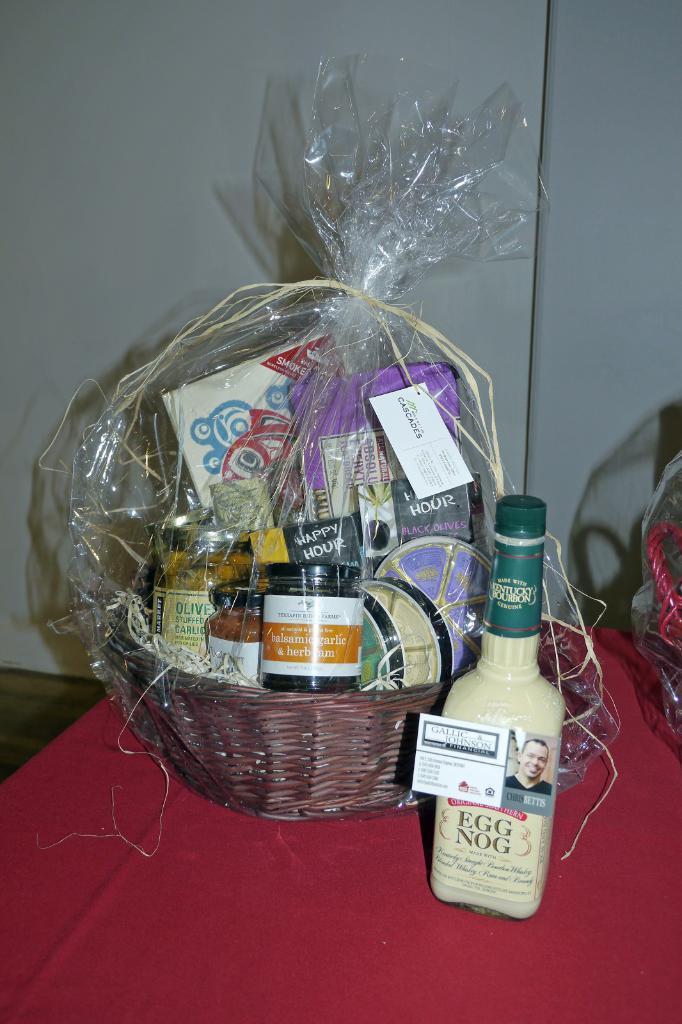What drink is next to the basket?
Provide a short and direct response. Egg nog. 